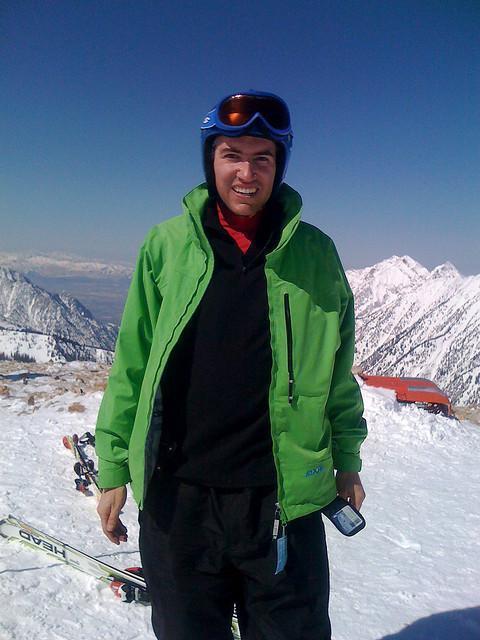What type of telephone is he using?
Answer the question by selecting the correct answer among the 4 following choices.
Options: Pay, cellular, rotary, landline. Cellular. 